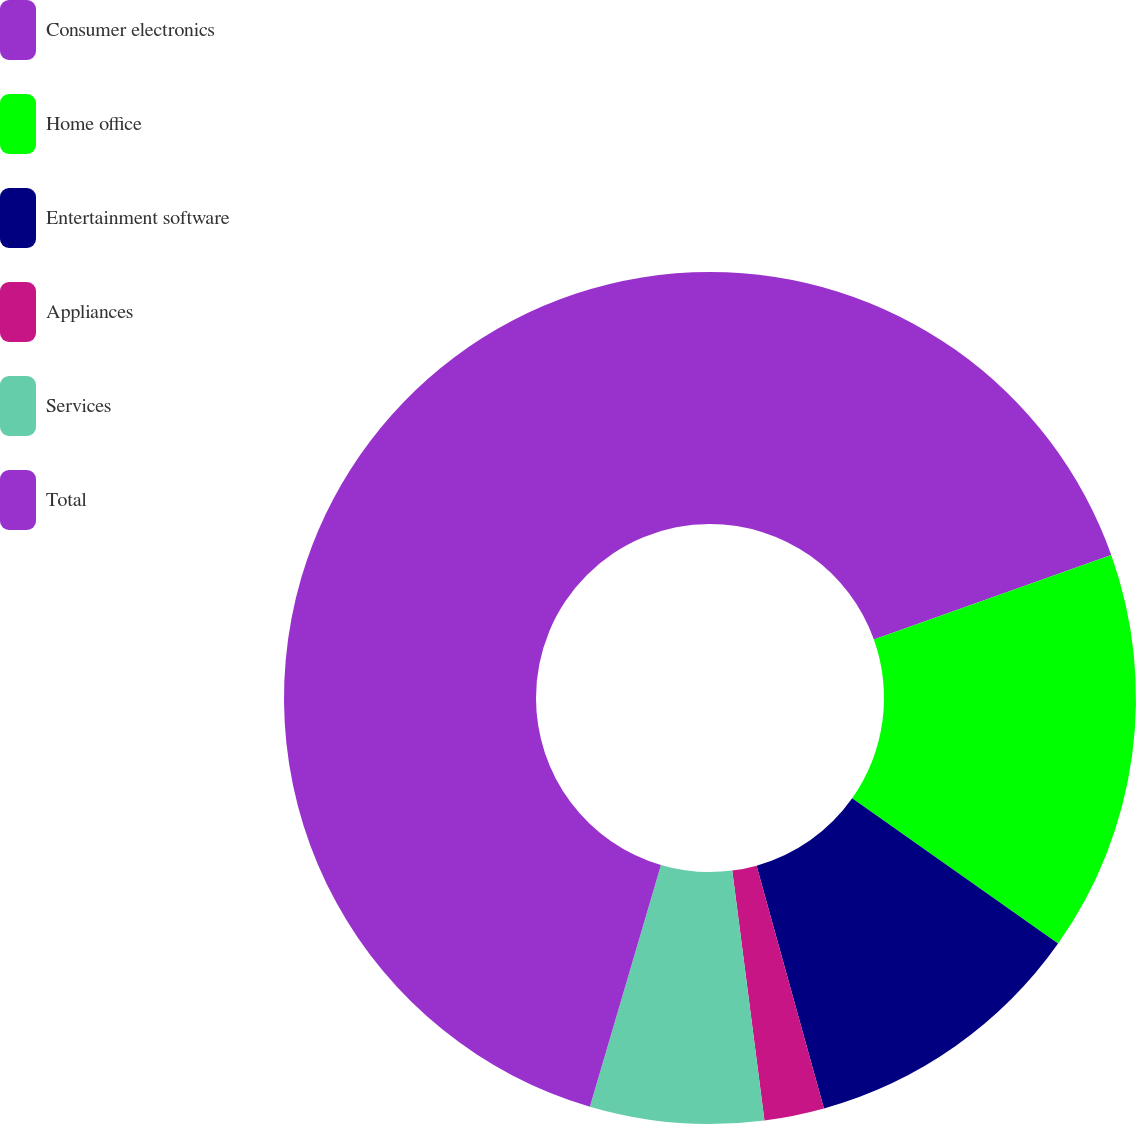Convert chart to OTSL. <chart><loc_0><loc_0><loc_500><loc_500><pie_chart><fcel>Consumer electronics<fcel>Home office<fcel>Entertainment software<fcel>Appliances<fcel>Services<fcel>Total<nl><fcel>19.55%<fcel>15.23%<fcel>10.91%<fcel>2.27%<fcel>6.59%<fcel>45.45%<nl></chart> 